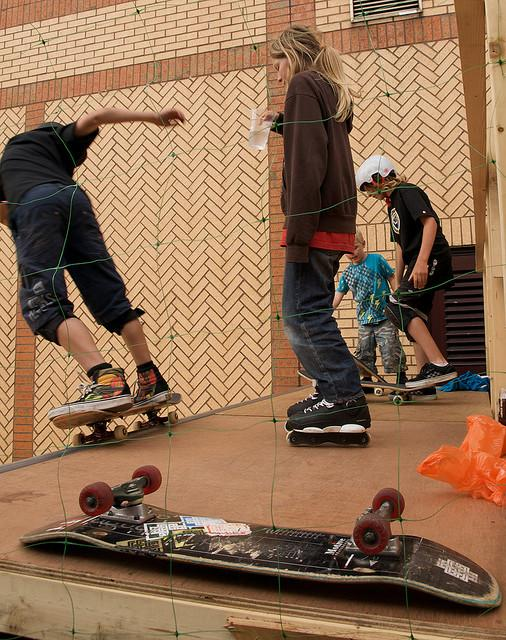This girl has similar hair color to what actress? reese witherspoon 